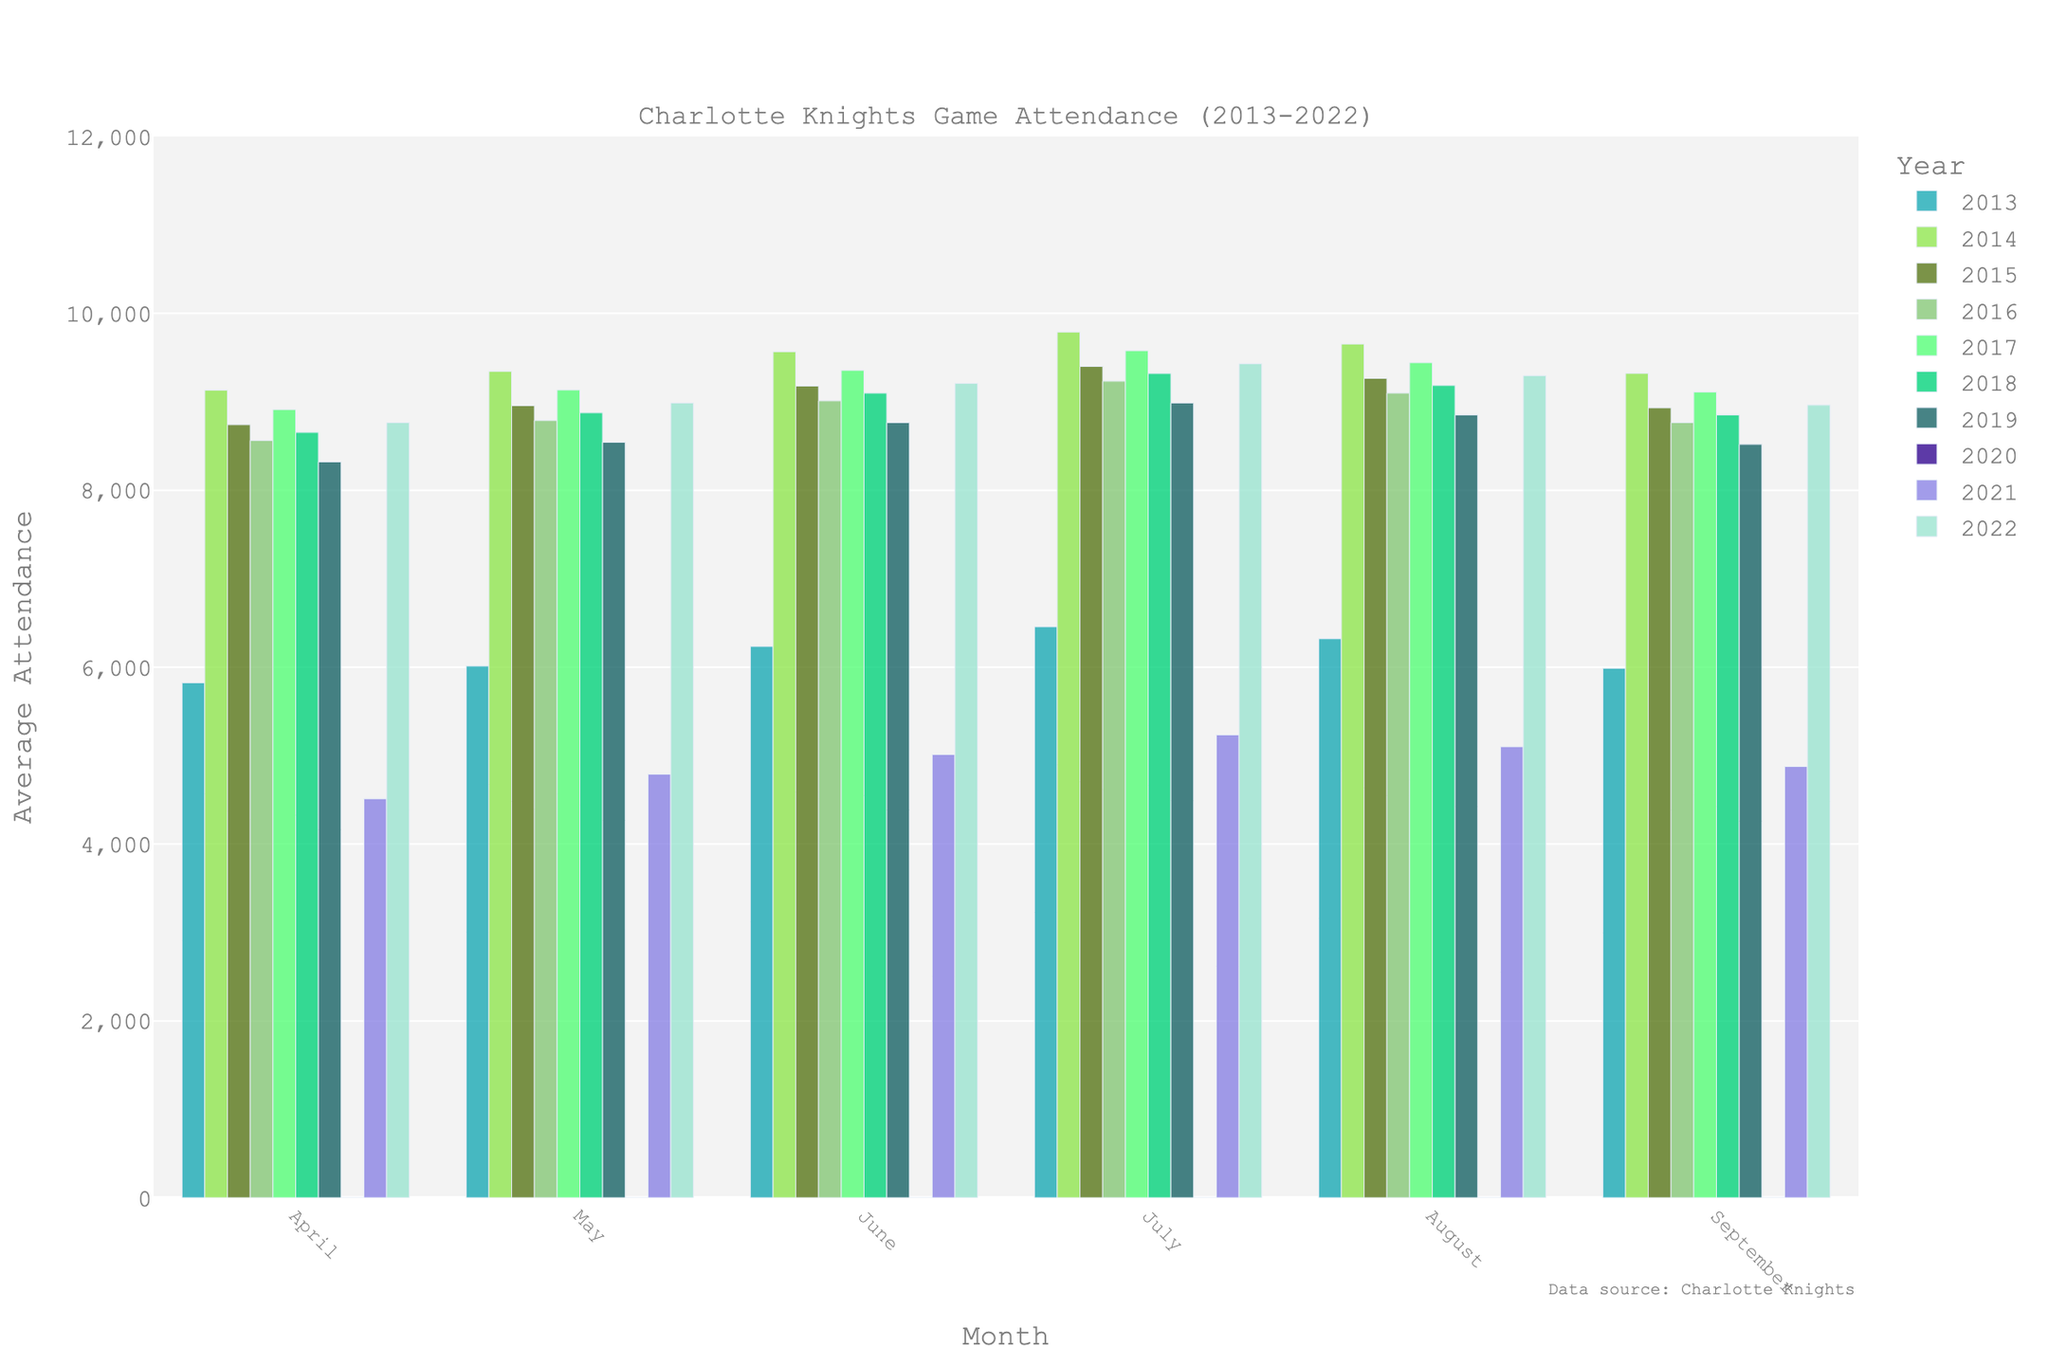How did attendance in April 2014 compare to April 2013? To find the difference, look at the height of the April bars for 2013 and 2014. April 2014's bar is significantly higher than April 2013's. The attendance in April 2013 was 5823, and in April 2014 it was 9132. Subtracting, 9132 - 5823 = 3309. So, April 2014 had 3309 more attendees than April 2013.
Answer: 3309 more Which year had the highest average attendance in July? Look at the height of the July bars across the years. The tallest bar appears to belong to 2014 with an attendance of 9789.
Answer: 2014 What was the average attendance for the months of May and June in 2021? For 2021, May had 4789 attendees and June had 5012. Summing them up gives 4789 + 5012 = 9801. Dividing by 2 to get the average, 9801 / 2 = 4900.5.
Answer: 4900.5 Compare the attendance in July and September of 2017. Was July's attendance greater, less, or equal to September's? Check the heights of the bars for July and September in 2017. July 2017 shows 9578 attendees, and September 2017 has 9110. Since 9578 is greater than 9110, July had higher attendance.
Answer: Greater Which month in any year had the lowest attendance, and what was the value? By comparing the smallest bars, the lowest attendance is in April 2020 with 0 attendees (perhaps due to the COVID-19 pandemic).
Answer: April 2020, 0 How much did the average attendance in August 2019 differ from August 2015? Compare the values for the August bars in these years. August 2015 had 9265 attendees and August 2019 had 8852. The difference is 9265 - 8852 = 413.
Answer: 413 In which year did the September average attendance surpass 9000 for the first time? Observe the bars for September across the years and look for the first bar surpassing 9000. In 2014, the attendance was 9321, surpassing 9000 for the first time.
Answer: 2014 Did the average attendance in June 2018 increase or decrease compared to June 2017? By how much? Compare the heights of the June bars for 2017 and 2018. June 2017 had 9356 attendees, and June 2018 had 9098. The attendance decreased, and the difference is 9356 - 9098 = 258.
Answer: Decrease by 258 Which year had the most significant decline in attendance from April to May? Look at the bars for April and May across the years and find the year with the largest drop. In 2021, April had 4512 attendees and May had 4789, which actually increased. The most significant drop appears in 2019, from 8321 in April to 8543 in May (though it's a slight increase rather than a drop). No significant decline is visibly represented, suggesting no considerable month-to-month drops visible directly from the bars.
Answer: No significant decline 